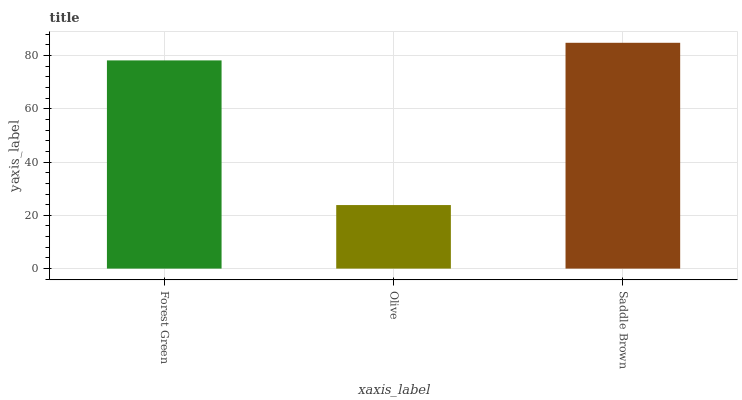Is Olive the minimum?
Answer yes or no. Yes. Is Saddle Brown the maximum?
Answer yes or no. Yes. Is Saddle Brown the minimum?
Answer yes or no. No. Is Olive the maximum?
Answer yes or no. No. Is Saddle Brown greater than Olive?
Answer yes or no. Yes. Is Olive less than Saddle Brown?
Answer yes or no. Yes. Is Olive greater than Saddle Brown?
Answer yes or no. No. Is Saddle Brown less than Olive?
Answer yes or no. No. Is Forest Green the high median?
Answer yes or no. Yes. Is Forest Green the low median?
Answer yes or no. Yes. Is Olive the high median?
Answer yes or no. No. Is Saddle Brown the low median?
Answer yes or no. No. 